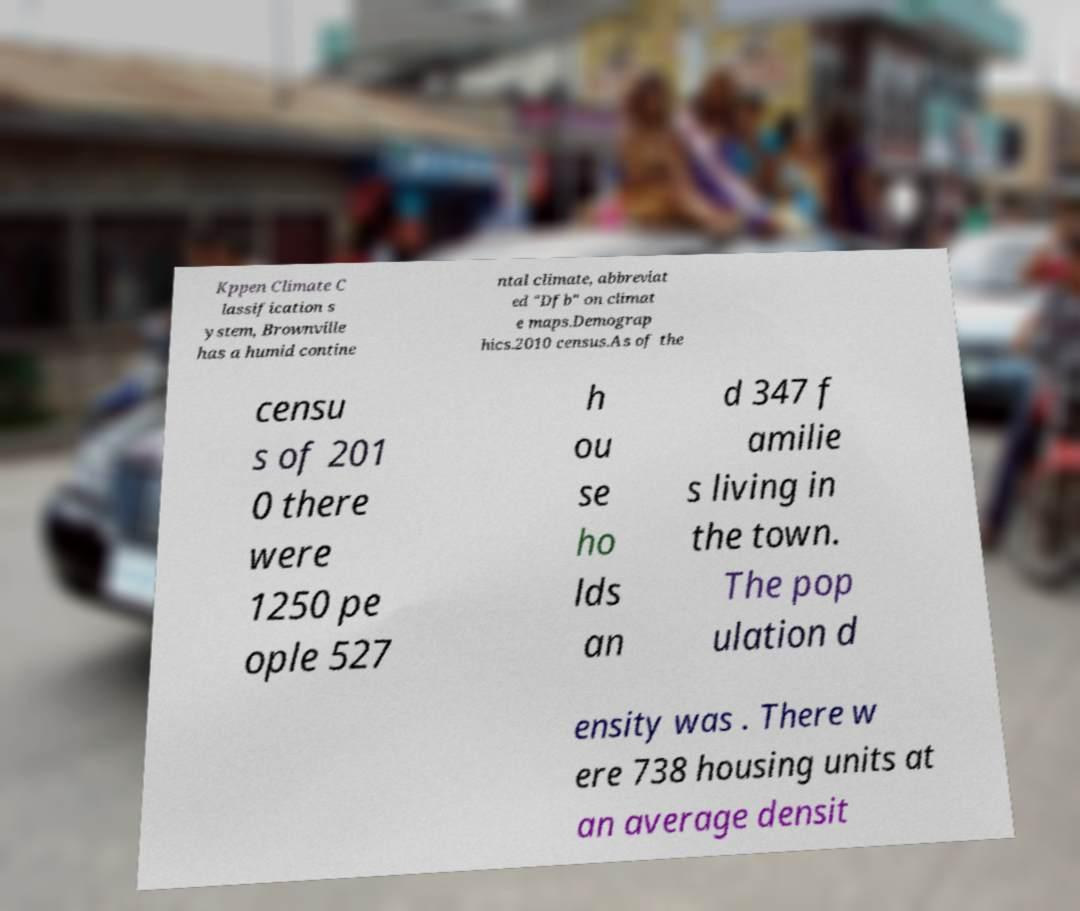Can you accurately transcribe the text from the provided image for me? Kppen Climate C lassification s ystem, Brownville has a humid contine ntal climate, abbreviat ed "Dfb" on climat e maps.Demograp hics.2010 census.As of the censu s of 201 0 there were 1250 pe ople 527 h ou se ho lds an d 347 f amilie s living in the town. The pop ulation d ensity was . There w ere 738 housing units at an average densit 